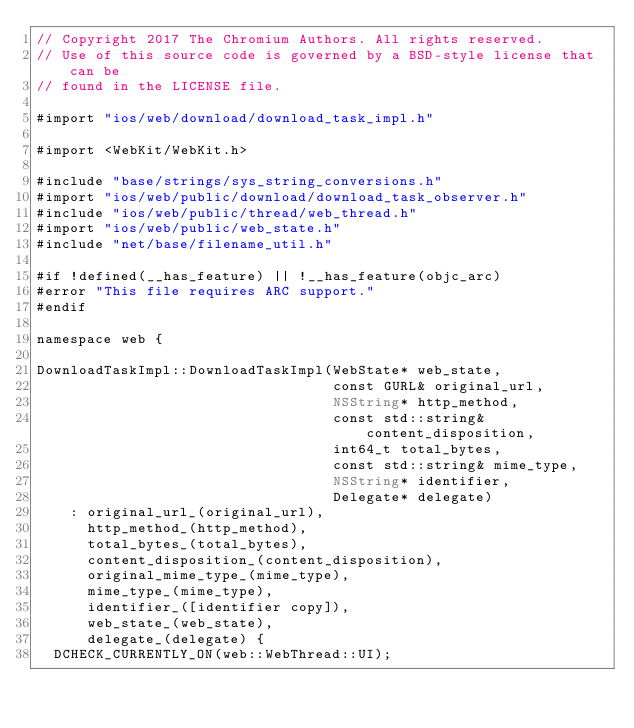<code> <loc_0><loc_0><loc_500><loc_500><_ObjectiveC_>// Copyright 2017 The Chromium Authors. All rights reserved.
// Use of this source code is governed by a BSD-style license that can be
// found in the LICENSE file.

#import "ios/web/download/download_task_impl.h"

#import <WebKit/WebKit.h>

#include "base/strings/sys_string_conversions.h"
#import "ios/web/public/download/download_task_observer.h"
#include "ios/web/public/thread/web_thread.h"
#import "ios/web/public/web_state.h"
#include "net/base/filename_util.h"

#if !defined(__has_feature) || !__has_feature(objc_arc)
#error "This file requires ARC support."
#endif

namespace web {

DownloadTaskImpl::DownloadTaskImpl(WebState* web_state,
                                   const GURL& original_url,
                                   NSString* http_method,
                                   const std::string& content_disposition,
                                   int64_t total_bytes,
                                   const std::string& mime_type,
                                   NSString* identifier,
                                   Delegate* delegate)
    : original_url_(original_url),
      http_method_(http_method),
      total_bytes_(total_bytes),
      content_disposition_(content_disposition),
      original_mime_type_(mime_type),
      mime_type_(mime_type),
      identifier_([identifier copy]),
      web_state_(web_state),
      delegate_(delegate) {
  DCHECK_CURRENTLY_ON(web::WebThread::UI);</code> 